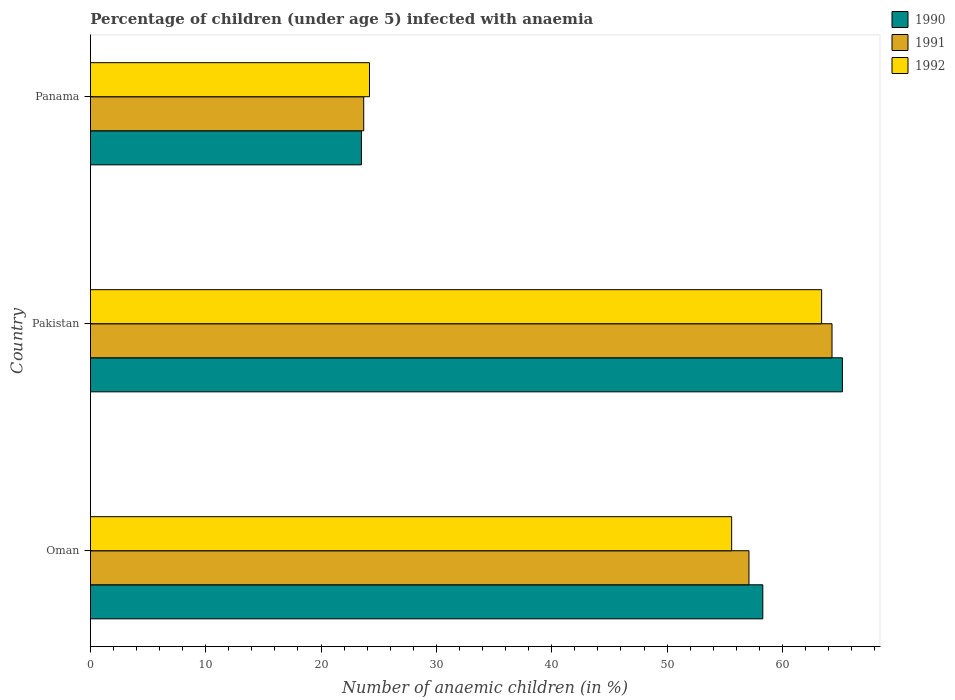How many groups of bars are there?
Ensure brevity in your answer.  3. How many bars are there on the 1st tick from the bottom?
Keep it short and to the point. 3. What is the label of the 3rd group of bars from the top?
Give a very brief answer. Oman. What is the percentage of children infected with anaemia in in 1992 in Panama?
Keep it short and to the point. 24.2. Across all countries, what is the maximum percentage of children infected with anaemia in in 1991?
Keep it short and to the point. 64.3. Across all countries, what is the minimum percentage of children infected with anaemia in in 1992?
Ensure brevity in your answer.  24.2. In which country was the percentage of children infected with anaemia in in 1990 minimum?
Make the answer very short. Panama. What is the total percentage of children infected with anaemia in in 1990 in the graph?
Offer a terse response. 147. What is the difference between the percentage of children infected with anaemia in in 1990 in Oman and that in Panama?
Your answer should be very brief. 34.8. What is the difference between the percentage of children infected with anaemia in in 1990 in Panama and the percentage of children infected with anaemia in in 1992 in Oman?
Your response must be concise. -32.1. What is the average percentage of children infected with anaemia in in 1992 per country?
Ensure brevity in your answer.  47.73. What is the difference between the percentage of children infected with anaemia in in 1990 and percentage of children infected with anaemia in in 1991 in Oman?
Your response must be concise. 1.2. What is the ratio of the percentage of children infected with anaemia in in 1991 in Oman to that in Panama?
Offer a terse response. 2.41. Is the difference between the percentage of children infected with anaemia in in 1990 in Oman and Panama greater than the difference between the percentage of children infected with anaemia in in 1991 in Oman and Panama?
Make the answer very short. Yes. What is the difference between the highest and the second highest percentage of children infected with anaemia in in 1992?
Give a very brief answer. 7.8. What is the difference between the highest and the lowest percentage of children infected with anaemia in in 1991?
Offer a terse response. 40.6. In how many countries, is the percentage of children infected with anaemia in in 1990 greater than the average percentage of children infected with anaemia in in 1990 taken over all countries?
Your answer should be very brief. 2. Is the sum of the percentage of children infected with anaemia in in 1990 in Oman and Panama greater than the maximum percentage of children infected with anaemia in in 1991 across all countries?
Make the answer very short. Yes. What does the 2nd bar from the top in Panama represents?
Offer a very short reply. 1991. What does the 2nd bar from the bottom in Oman represents?
Give a very brief answer. 1991. Is it the case that in every country, the sum of the percentage of children infected with anaemia in in 1990 and percentage of children infected with anaemia in in 1992 is greater than the percentage of children infected with anaemia in in 1991?
Make the answer very short. Yes. How many countries are there in the graph?
Give a very brief answer. 3. What is the difference between two consecutive major ticks on the X-axis?
Make the answer very short. 10. Does the graph contain grids?
Offer a terse response. No. Where does the legend appear in the graph?
Your response must be concise. Top right. How many legend labels are there?
Your response must be concise. 3. What is the title of the graph?
Keep it short and to the point. Percentage of children (under age 5) infected with anaemia. Does "1985" appear as one of the legend labels in the graph?
Keep it short and to the point. No. What is the label or title of the X-axis?
Provide a succinct answer. Number of anaemic children (in %). What is the Number of anaemic children (in %) of 1990 in Oman?
Your response must be concise. 58.3. What is the Number of anaemic children (in %) of 1991 in Oman?
Ensure brevity in your answer.  57.1. What is the Number of anaemic children (in %) in 1992 in Oman?
Your answer should be compact. 55.6. What is the Number of anaemic children (in %) of 1990 in Pakistan?
Offer a terse response. 65.2. What is the Number of anaemic children (in %) in 1991 in Pakistan?
Offer a terse response. 64.3. What is the Number of anaemic children (in %) in 1992 in Pakistan?
Offer a very short reply. 63.4. What is the Number of anaemic children (in %) in 1991 in Panama?
Your response must be concise. 23.7. What is the Number of anaemic children (in %) of 1992 in Panama?
Give a very brief answer. 24.2. Across all countries, what is the maximum Number of anaemic children (in %) of 1990?
Provide a succinct answer. 65.2. Across all countries, what is the maximum Number of anaemic children (in %) in 1991?
Provide a succinct answer. 64.3. Across all countries, what is the maximum Number of anaemic children (in %) of 1992?
Ensure brevity in your answer.  63.4. Across all countries, what is the minimum Number of anaemic children (in %) of 1991?
Make the answer very short. 23.7. Across all countries, what is the minimum Number of anaemic children (in %) of 1992?
Provide a succinct answer. 24.2. What is the total Number of anaemic children (in %) in 1990 in the graph?
Your answer should be very brief. 147. What is the total Number of anaemic children (in %) in 1991 in the graph?
Your answer should be very brief. 145.1. What is the total Number of anaemic children (in %) in 1992 in the graph?
Your answer should be very brief. 143.2. What is the difference between the Number of anaemic children (in %) of 1990 in Oman and that in Pakistan?
Provide a short and direct response. -6.9. What is the difference between the Number of anaemic children (in %) of 1990 in Oman and that in Panama?
Make the answer very short. 34.8. What is the difference between the Number of anaemic children (in %) in 1991 in Oman and that in Panama?
Provide a short and direct response. 33.4. What is the difference between the Number of anaemic children (in %) in 1992 in Oman and that in Panama?
Give a very brief answer. 31.4. What is the difference between the Number of anaemic children (in %) in 1990 in Pakistan and that in Panama?
Your answer should be compact. 41.7. What is the difference between the Number of anaemic children (in %) of 1991 in Pakistan and that in Panama?
Your answer should be very brief. 40.6. What is the difference between the Number of anaemic children (in %) in 1992 in Pakistan and that in Panama?
Make the answer very short. 39.2. What is the difference between the Number of anaemic children (in %) in 1990 in Oman and the Number of anaemic children (in %) in 1991 in Pakistan?
Provide a succinct answer. -6. What is the difference between the Number of anaemic children (in %) in 1991 in Oman and the Number of anaemic children (in %) in 1992 in Pakistan?
Your response must be concise. -6.3. What is the difference between the Number of anaemic children (in %) of 1990 in Oman and the Number of anaemic children (in %) of 1991 in Panama?
Your answer should be compact. 34.6. What is the difference between the Number of anaemic children (in %) of 1990 in Oman and the Number of anaemic children (in %) of 1992 in Panama?
Provide a short and direct response. 34.1. What is the difference between the Number of anaemic children (in %) of 1991 in Oman and the Number of anaemic children (in %) of 1992 in Panama?
Your response must be concise. 32.9. What is the difference between the Number of anaemic children (in %) of 1990 in Pakistan and the Number of anaemic children (in %) of 1991 in Panama?
Make the answer very short. 41.5. What is the difference between the Number of anaemic children (in %) of 1991 in Pakistan and the Number of anaemic children (in %) of 1992 in Panama?
Offer a terse response. 40.1. What is the average Number of anaemic children (in %) in 1990 per country?
Ensure brevity in your answer.  49. What is the average Number of anaemic children (in %) of 1991 per country?
Give a very brief answer. 48.37. What is the average Number of anaemic children (in %) in 1992 per country?
Provide a short and direct response. 47.73. What is the difference between the Number of anaemic children (in %) of 1990 and Number of anaemic children (in %) of 1991 in Oman?
Ensure brevity in your answer.  1.2. What is the difference between the Number of anaemic children (in %) of 1990 and Number of anaemic children (in %) of 1992 in Oman?
Your response must be concise. 2.7. What is the difference between the Number of anaemic children (in %) in 1991 and Number of anaemic children (in %) in 1992 in Oman?
Provide a succinct answer. 1.5. What is the difference between the Number of anaemic children (in %) of 1990 and Number of anaemic children (in %) of 1991 in Pakistan?
Provide a short and direct response. 0.9. What is the difference between the Number of anaemic children (in %) of 1990 and Number of anaemic children (in %) of 1992 in Pakistan?
Provide a short and direct response. 1.8. What is the difference between the Number of anaemic children (in %) of 1990 and Number of anaemic children (in %) of 1991 in Panama?
Ensure brevity in your answer.  -0.2. What is the ratio of the Number of anaemic children (in %) in 1990 in Oman to that in Pakistan?
Your answer should be very brief. 0.89. What is the ratio of the Number of anaemic children (in %) in 1991 in Oman to that in Pakistan?
Provide a short and direct response. 0.89. What is the ratio of the Number of anaemic children (in %) of 1992 in Oman to that in Pakistan?
Make the answer very short. 0.88. What is the ratio of the Number of anaemic children (in %) in 1990 in Oman to that in Panama?
Keep it short and to the point. 2.48. What is the ratio of the Number of anaemic children (in %) in 1991 in Oman to that in Panama?
Keep it short and to the point. 2.41. What is the ratio of the Number of anaemic children (in %) of 1992 in Oman to that in Panama?
Your answer should be very brief. 2.3. What is the ratio of the Number of anaemic children (in %) of 1990 in Pakistan to that in Panama?
Offer a terse response. 2.77. What is the ratio of the Number of anaemic children (in %) in 1991 in Pakistan to that in Panama?
Keep it short and to the point. 2.71. What is the ratio of the Number of anaemic children (in %) of 1992 in Pakistan to that in Panama?
Offer a terse response. 2.62. What is the difference between the highest and the second highest Number of anaemic children (in %) of 1990?
Keep it short and to the point. 6.9. What is the difference between the highest and the lowest Number of anaemic children (in %) of 1990?
Give a very brief answer. 41.7. What is the difference between the highest and the lowest Number of anaemic children (in %) of 1991?
Ensure brevity in your answer.  40.6. What is the difference between the highest and the lowest Number of anaemic children (in %) of 1992?
Provide a succinct answer. 39.2. 